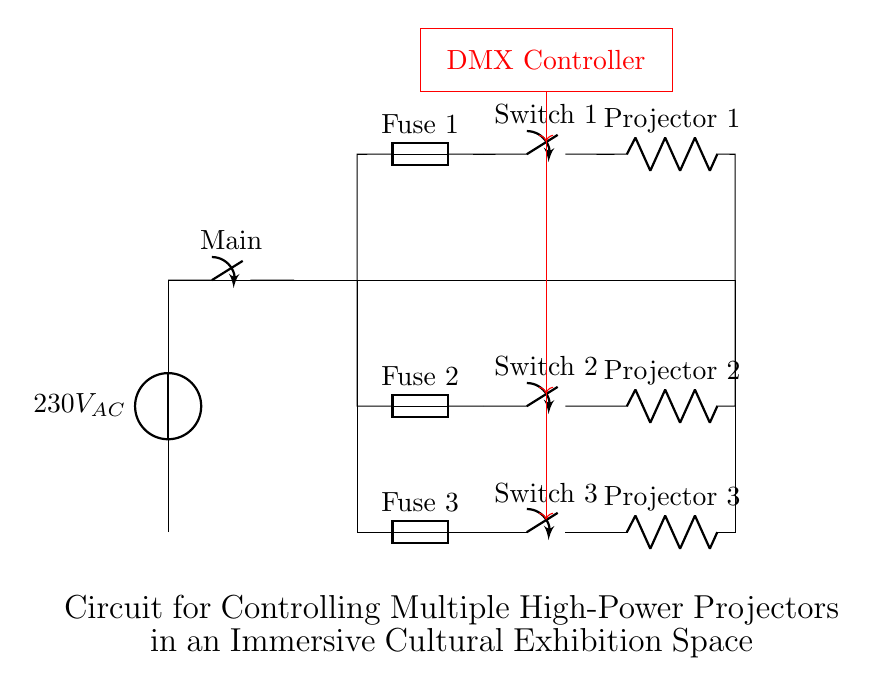What is the voltage of this circuit? The circuit operates at 230V AC, which is indicated by the voltage source labeled in the diagram.
Answer: 230V AC What do the red arrows indicate in the circuit? The red arrows represent the connections from the DMX Controller to the switches for each projector, signaling control pathways in the circuit.
Answer: Control pathways How many fuses are present in this circuit? There are three fuses labeled Fuse 1, Fuse 2, and Fuse 3, indicating overcurrent protection for each projector circuit.
Answer: Three fuses What type of component is used to control each projector? Each projector circuit is controlled by a switch, labeled Switch 1, Switch 2, and Switch 3 in the circuit diagram.
Answer: Switch What is the purpose of the DMX Controller in this circuit? The DMX Controller is used to manage the operation of the projectors, allowing for synchronized control of their performance during the exhibition.
Answer: Synchronized control How many projectors can be controlled by the setup in the diagram? The circuit is designed to control three projectors, as indicated by the separate circuits and switches associated with Projector 1, Projector 2, and Projector 3.
Answer: Three projectors What is the significance of the main switch in this circuit? The main switch allows for the entire circuit to be turned on or off, providing a control point for the power supply to all projectors.
Answer: Control point 